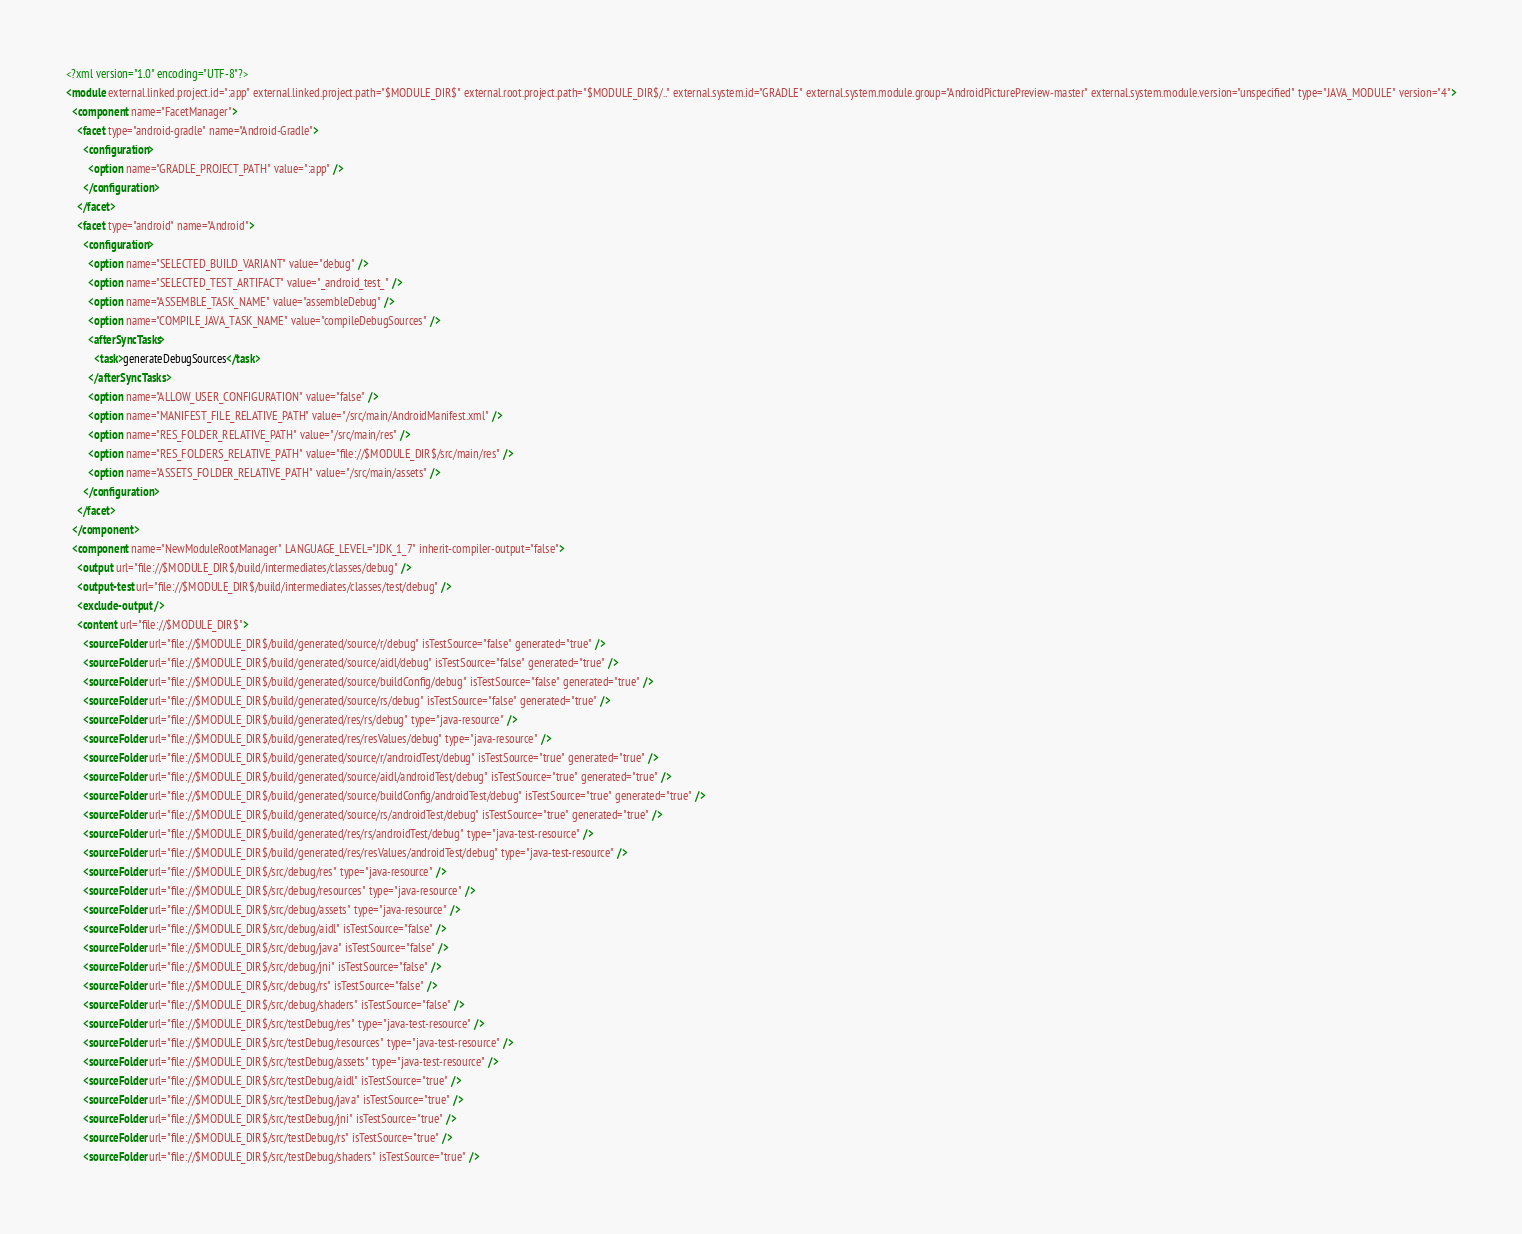Convert code to text. <code><loc_0><loc_0><loc_500><loc_500><_XML_><?xml version="1.0" encoding="UTF-8"?>
<module external.linked.project.id=":app" external.linked.project.path="$MODULE_DIR$" external.root.project.path="$MODULE_DIR$/.." external.system.id="GRADLE" external.system.module.group="AndroidPicturePreview-master" external.system.module.version="unspecified" type="JAVA_MODULE" version="4">
  <component name="FacetManager">
    <facet type="android-gradle" name="Android-Gradle">
      <configuration>
        <option name="GRADLE_PROJECT_PATH" value=":app" />
      </configuration>
    </facet>
    <facet type="android" name="Android">
      <configuration>
        <option name="SELECTED_BUILD_VARIANT" value="debug" />
        <option name="SELECTED_TEST_ARTIFACT" value="_android_test_" />
        <option name="ASSEMBLE_TASK_NAME" value="assembleDebug" />
        <option name="COMPILE_JAVA_TASK_NAME" value="compileDebugSources" />
        <afterSyncTasks>
          <task>generateDebugSources</task>
        </afterSyncTasks>
        <option name="ALLOW_USER_CONFIGURATION" value="false" />
        <option name="MANIFEST_FILE_RELATIVE_PATH" value="/src/main/AndroidManifest.xml" />
        <option name="RES_FOLDER_RELATIVE_PATH" value="/src/main/res" />
        <option name="RES_FOLDERS_RELATIVE_PATH" value="file://$MODULE_DIR$/src/main/res" />
        <option name="ASSETS_FOLDER_RELATIVE_PATH" value="/src/main/assets" />
      </configuration>
    </facet>
  </component>
  <component name="NewModuleRootManager" LANGUAGE_LEVEL="JDK_1_7" inherit-compiler-output="false">
    <output url="file://$MODULE_DIR$/build/intermediates/classes/debug" />
    <output-test url="file://$MODULE_DIR$/build/intermediates/classes/test/debug" />
    <exclude-output />
    <content url="file://$MODULE_DIR$">
      <sourceFolder url="file://$MODULE_DIR$/build/generated/source/r/debug" isTestSource="false" generated="true" />
      <sourceFolder url="file://$MODULE_DIR$/build/generated/source/aidl/debug" isTestSource="false" generated="true" />
      <sourceFolder url="file://$MODULE_DIR$/build/generated/source/buildConfig/debug" isTestSource="false" generated="true" />
      <sourceFolder url="file://$MODULE_DIR$/build/generated/source/rs/debug" isTestSource="false" generated="true" />
      <sourceFolder url="file://$MODULE_DIR$/build/generated/res/rs/debug" type="java-resource" />
      <sourceFolder url="file://$MODULE_DIR$/build/generated/res/resValues/debug" type="java-resource" />
      <sourceFolder url="file://$MODULE_DIR$/build/generated/source/r/androidTest/debug" isTestSource="true" generated="true" />
      <sourceFolder url="file://$MODULE_DIR$/build/generated/source/aidl/androidTest/debug" isTestSource="true" generated="true" />
      <sourceFolder url="file://$MODULE_DIR$/build/generated/source/buildConfig/androidTest/debug" isTestSource="true" generated="true" />
      <sourceFolder url="file://$MODULE_DIR$/build/generated/source/rs/androidTest/debug" isTestSource="true" generated="true" />
      <sourceFolder url="file://$MODULE_DIR$/build/generated/res/rs/androidTest/debug" type="java-test-resource" />
      <sourceFolder url="file://$MODULE_DIR$/build/generated/res/resValues/androidTest/debug" type="java-test-resource" />
      <sourceFolder url="file://$MODULE_DIR$/src/debug/res" type="java-resource" />
      <sourceFolder url="file://$MODULE_DIR$/src/debug/resources" type="java-resource" />
      <sourceFolder url="file://$MODULE_DIR$/src/debug/assets" type="java-resource" />
      <sourceFolder url="file://$MODULE_DIR$/src/debug/aidl" isTestSource="false" />
      <sourceFolder url="file://$MODULE_DIR$/src/debug/java" isTestSource="false" />
      <sourceFolder url="file://$MODULE_DIR$/src/debug/jni" isTestSource="false" />
      <sourceFolder url="file://$MODULE_DIR$/src/debug/rs" isTestSource="false" />
      <sourceFolder url="file://$MODULE_DIR$/src/debug/shaders" isTestSource="false" />
      <sourceFolder url="file://$MODULE_DIR$/src/testDebug/res" type="java-test-resource" />
      <sourceFolder url="file://$MODULE_DIR$/src/testDebug/resources" type="java-test-resource" />
      <sourceFolder url="file://$MODULE_DIR$/src/testDebug/assets" type="java-test-resource" />
      <sourceFolder url="file://$MODULE_DIR$/src/testDebug/aidl" isTestSource="true" />
      <sourceFolder url="file://$MODULE_DIR$/src/testDebug/java" isTestSource="true" />
      <sourceFolder url="file://$MODULE_DIR$/src/testDebug/jni" isTestSource="true" />
      <sourceFolder url="file://$MODULE_DIR$/src/testDebug/rs" isTestSource="true" />
      <sourceFolder url="file://$MODULE_DIR$/src/testDebug/shaders" isTestSource="true" /></code> 